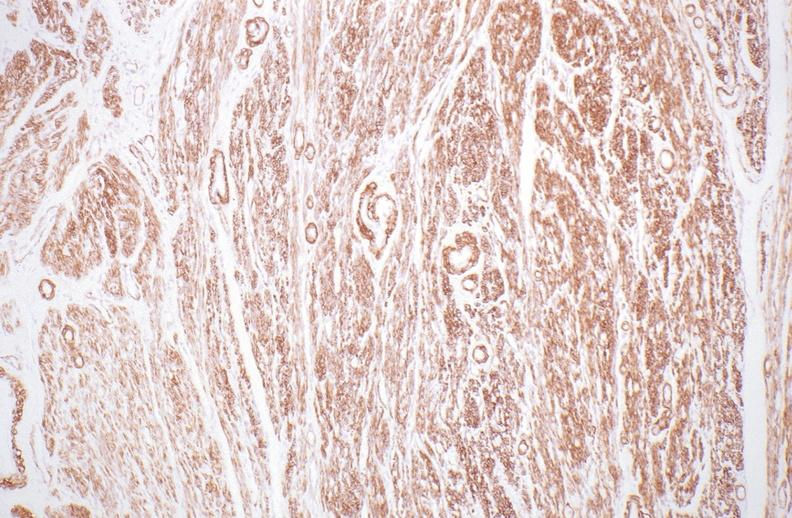what is present?
Answer the question using a single word or phrase. Female reproductive 